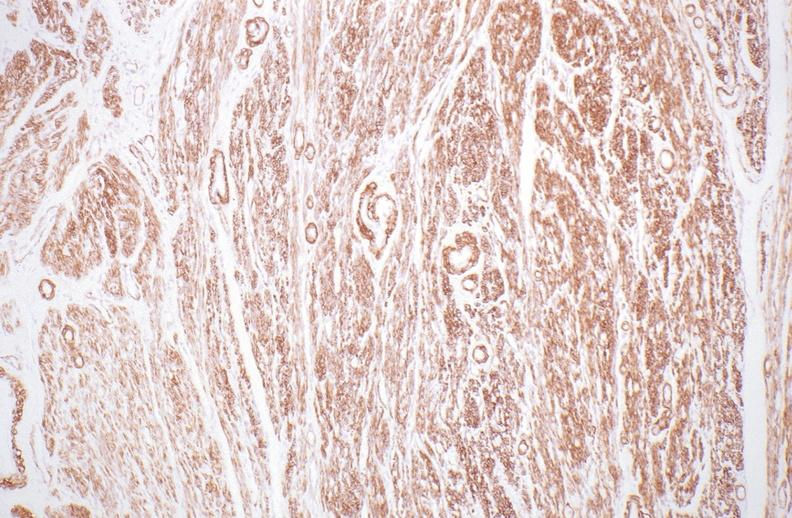what is present?
Answer the question using a single word or phrase. Female reproductive 